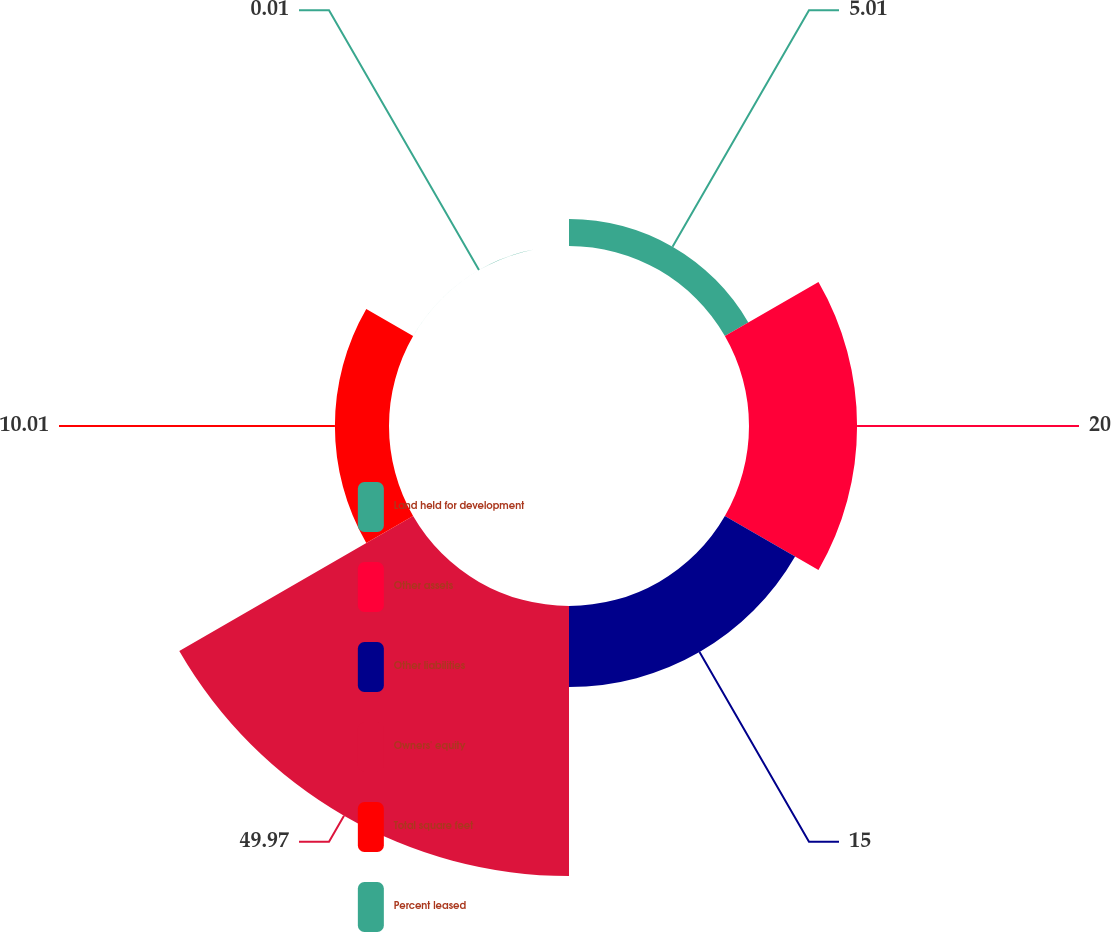Convert chart. <chart><loc_0><loc_0><loc_500><loc_500><pie_chart><fcel>Land held for development<fcel>Other assets<fcel>Other liabilities<fcel>Owners' equity<fcel>Total square feet<fcel>Percent leased<nl><fcel>5.01%<fcel>20.0%<fcel>15.0%<fcel>49.97%<fcel>10.01%<fcel>0.01%<nl></chart> 